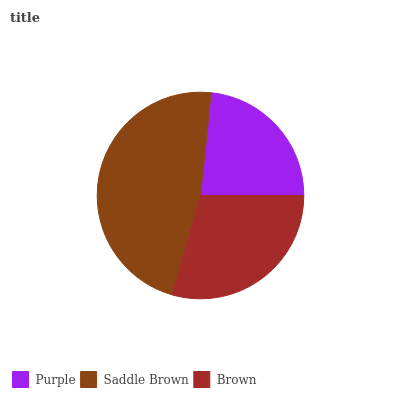Is Purple the minimum?
Answer yes or no. Yes. Is Saddle Brown the maximum?
Answer yes or no. Yes. Is Brown the minimum?
Answer yes or no. No. Is Brown the maximum?
Answer yes or no. No. Is Saddle Brown greater than Brown?
Answer yes or no. Yes. Is Brown less than Saddle Brown?
Answer yes or no. Yes. Is Brown greater than Saddle Brown?
Answer yes or no. No. Is Saddle Brown less than Brown?
Answer yes or no. No. Is Brown the high median?
Answer yes or no. Yes. Is Brown the low median?
Answer yes or no. Yes. Is Purple the high median?
Answer yes or no. No. Is Saddle Brown the low median?
Answer yes or no. No. 